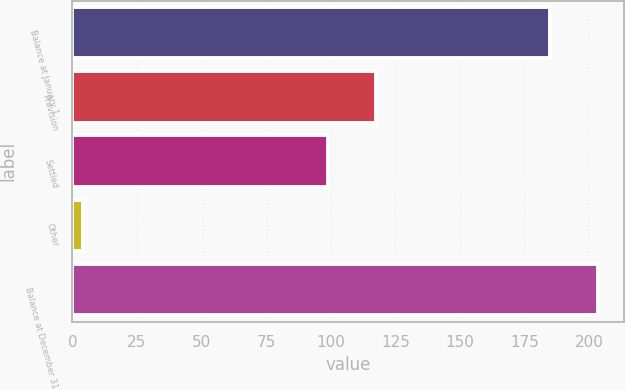<chart> <loc_0><loc_0><loc_500><loc_500><bar_chart><fcel>Balance at January 1<fcel>Provision<fcel>Settled<fcel>Other<fcel>Balance at December 31<nl><fcel>185<fcel>117.5<fcel>99<fcel>4<fcel>203.5<nl></chart> 